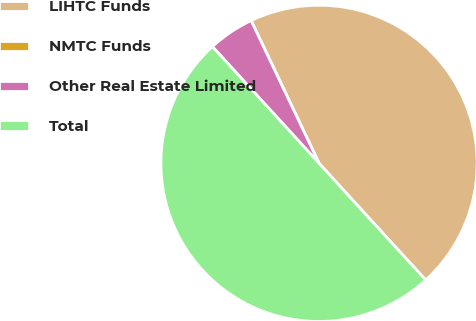Convert chart. <chart><loc_0><loc_0><loc_500><loc_500><pie_chart><fcel>LIHTC Funds<fcel>NMTC Funds<fcel>Other Real Estate Limited<fcel>Total<nl><fcel>45.29%<fcel>0.0%<fcel>4.71%<fcel>50.0%<nl></chart> 